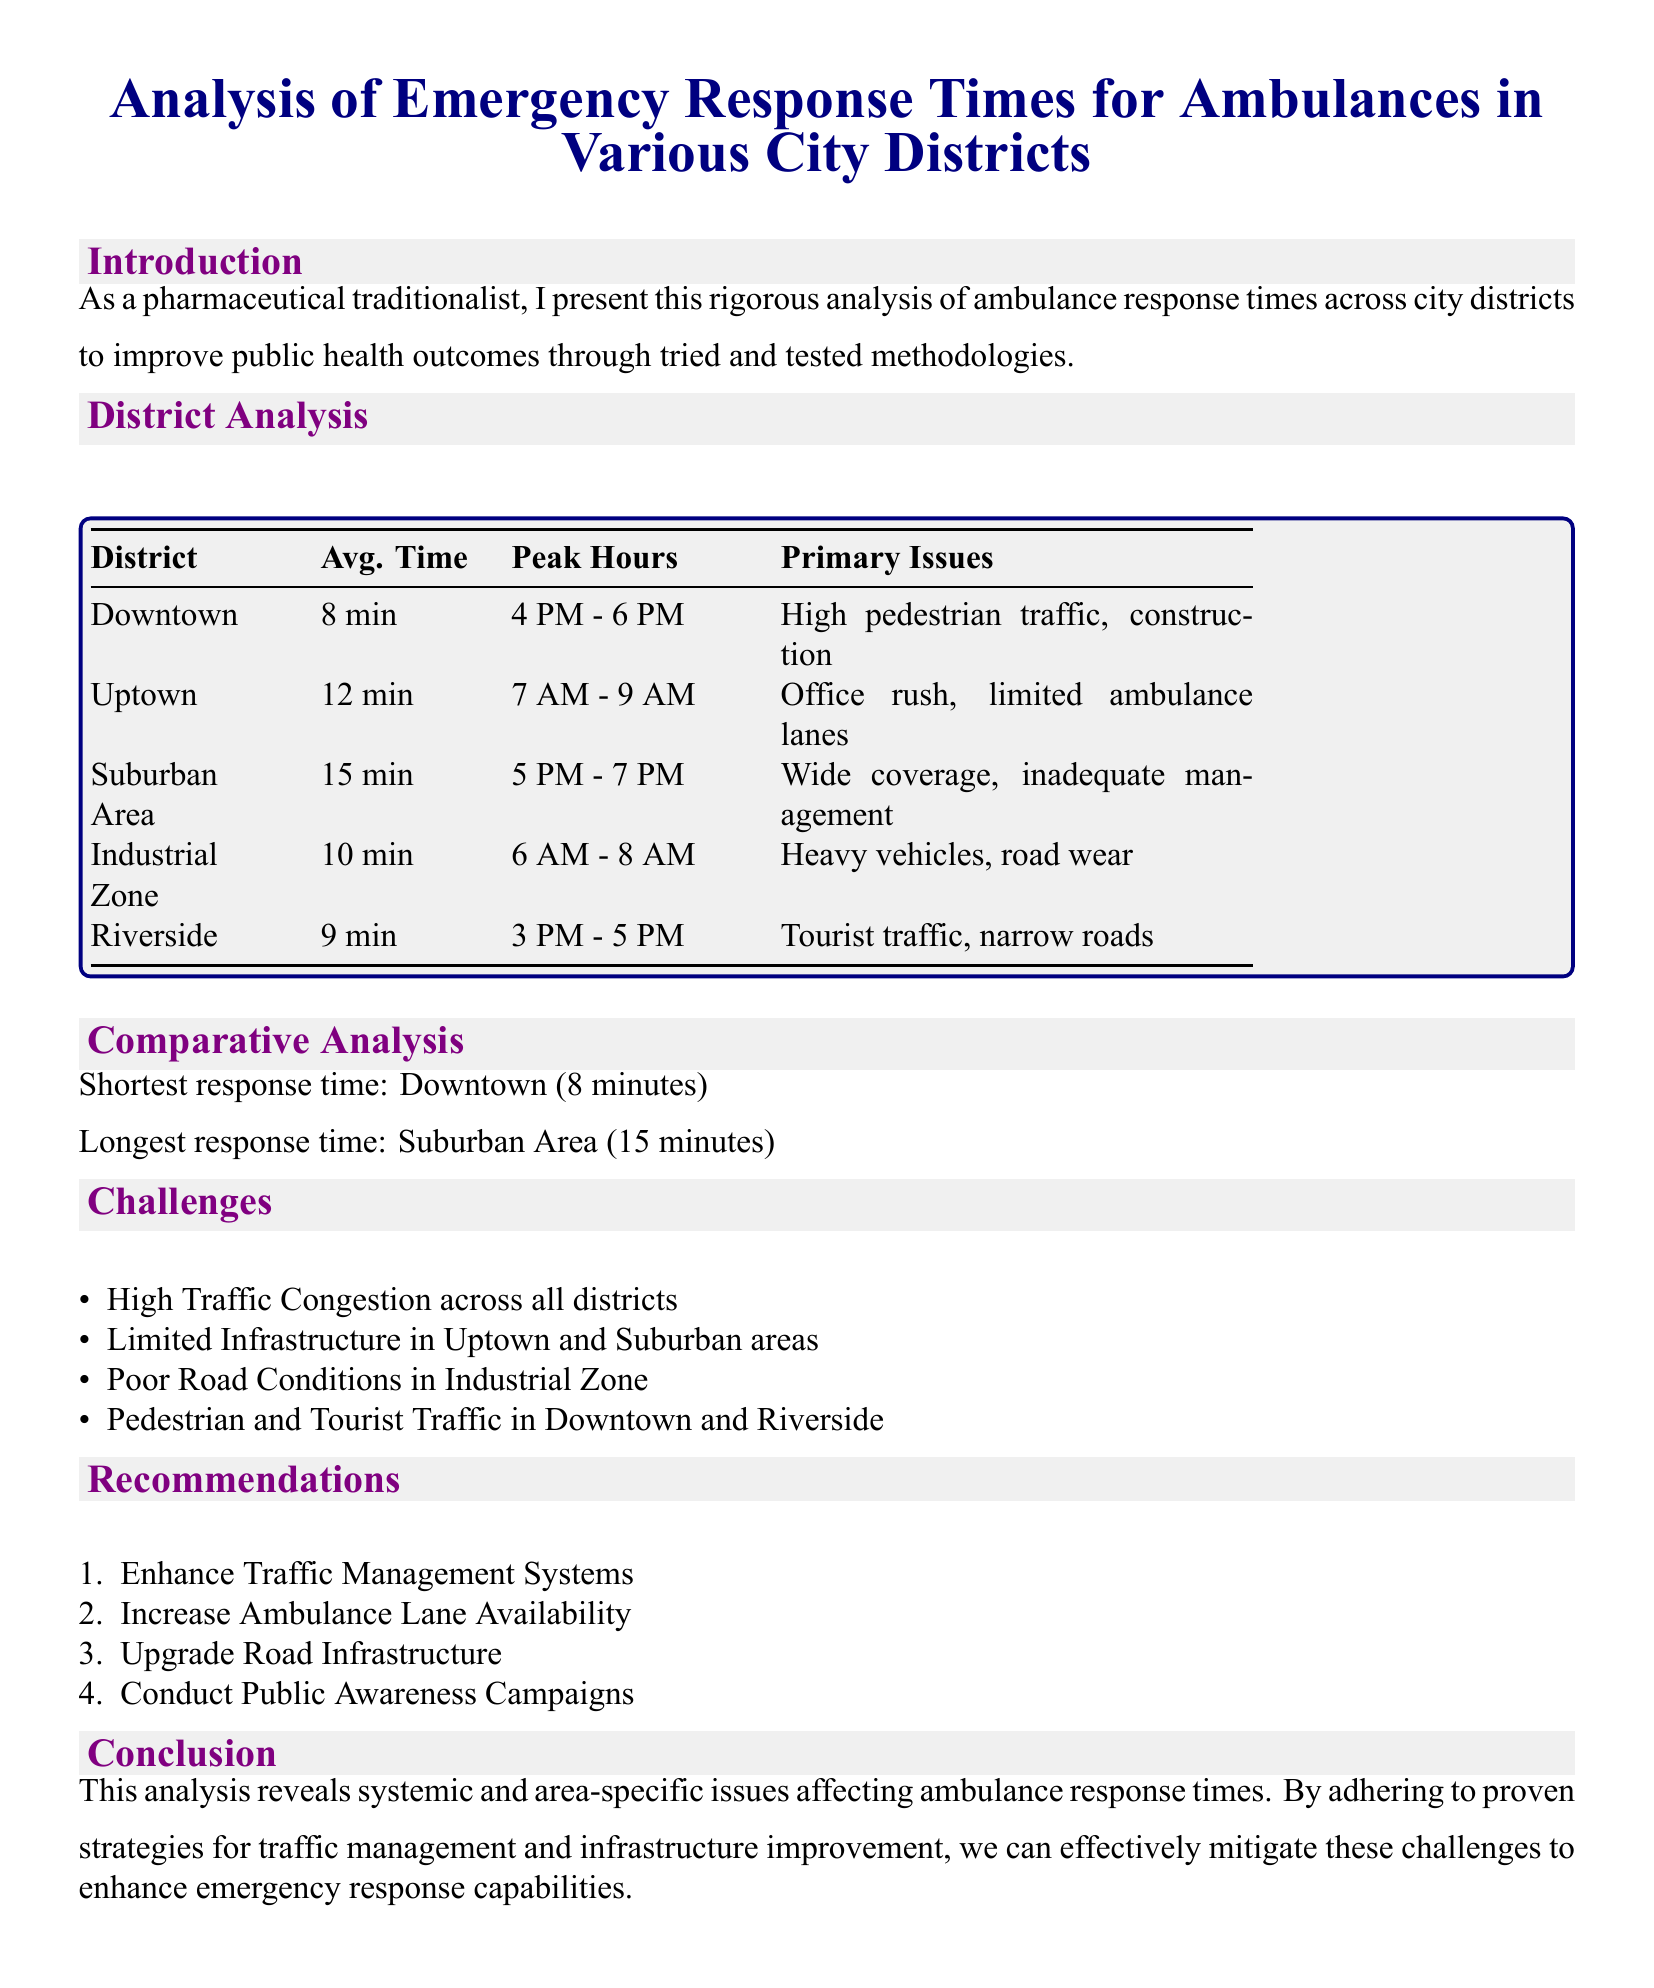What is the average response time in Downtown? The average response time in Downtown is found in the District Analysis section.
Answer: 8 min What is the primary issue in Uptown? The primary issue in Uptown is listed under District Analysis.
Answer: Office rush, limited ambulance lanes Which district has the longest response time? The district with the longest response time is mentioned in the Comparative Analysis section.
Answer: Suburban Area What are the peak hours for the Industrial Zone? The peak hours for the Industrial Zone can be found in the District Analysis table.
Answer: 6 AM - 8 AM What specific challenge is noted for all districts? The document notes a specific challenge that affects all districts under the Challenges section.
Answer: High Traffic Congestion How many recommendations are made in the report? The number of recommendations is indicated in the Recommendations section.
Answer: 4 Which area experiences high tourist traffic? The area that experiences high tourist traffic is specified under District Analysis.
Answer: Riverside What is recommended to enhance emergency response capabilities? The type of recommendations made to improve response capabilities is discussed in the Recommendations section.
Answer: Traffic Management Systems 